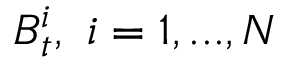<formula> <loc_0><loc_0><loc_500><loc_500>B _ { t } ^ { i } , \ i = 1 , \dots , N</formula> 